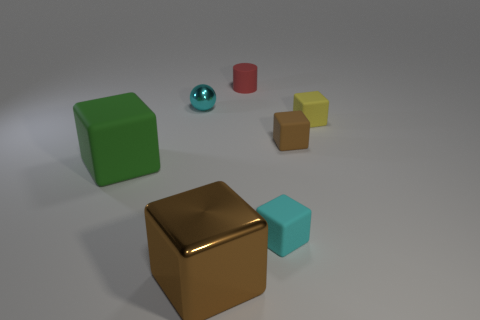Is there any other thing that has the same shape as the small metallic thing?
Offer a terse response. No. What shape is the large thing on the left side of the cyan sphere?
Give a very brief answer. Cube. Is the shape of the big green matte thing the same as the cyan rubber thing?
Give a very brief answer. Yes. There is a cyan matte object that is the same shape as the yellow matte thing; what is its size?
Provide a short and direct response. Small. Is the size of the shiny thing that is on the right side of the sphere the same as the green rubber block?
Provide a short and direct response. Yes. What size is the matte object that is both in front of the brown matte cube and to the right of the rubber cylinder?
Your answer should be very brief. Small. What is the material of the other thing that is the same color as the small metal thing?
Provide a succinct answer. Rubber. What number of other cubes are the same color as the metal cube?
Provide a short and direct response. 1. Are there the same number of big brown shiny things that are on the left side of the large metallic cube and matte cubes?
Give a very brief answer. No. What color is the large metallic block?
Provide a succinct answer. Brown. 